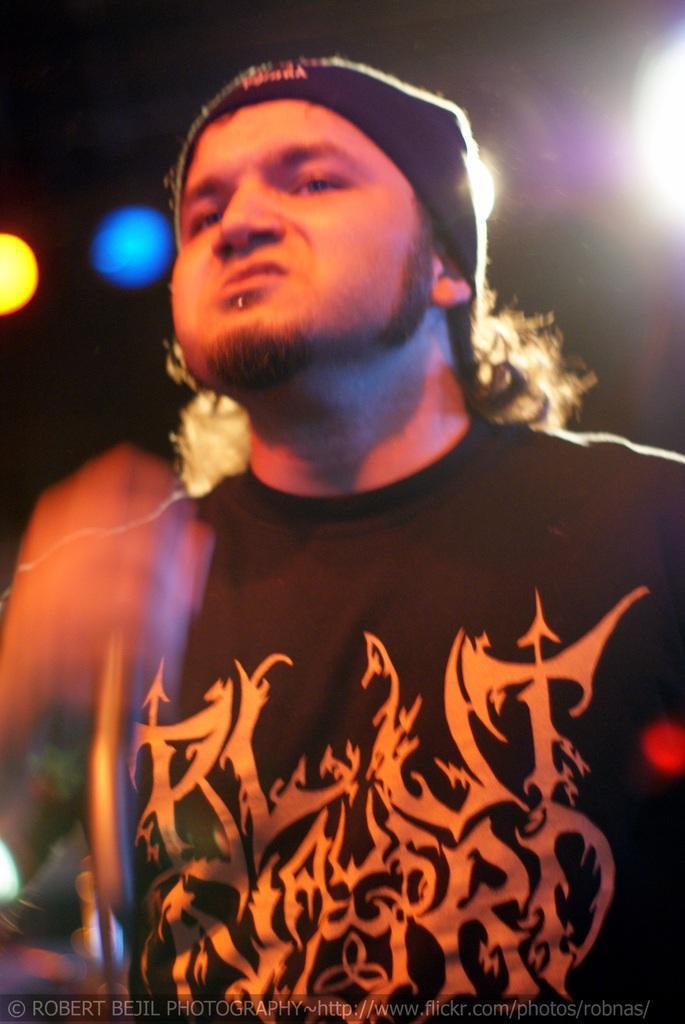Could you give a brief overview of what you see in this image? In the image there is a man,he is wearing a band around his head and the background of the man is dark. 